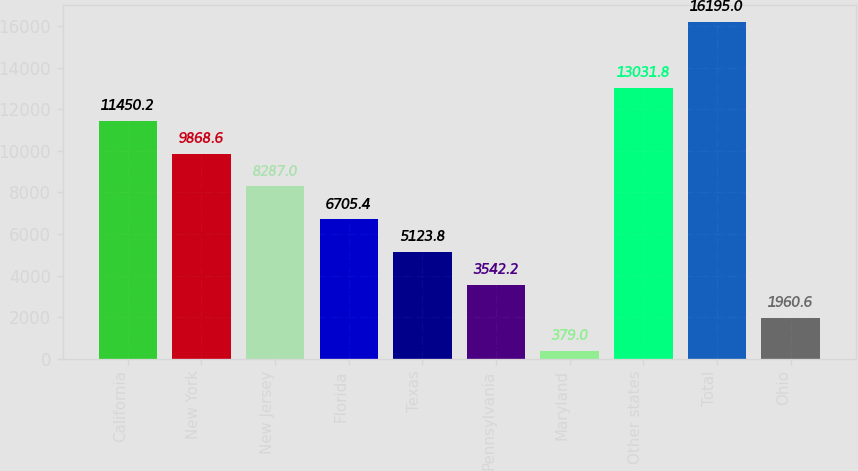Convert chart to OTSL. <chart><loc_0><loc_0><loc_500><loc_500><bar_chart><fcel>California<fcel>New York<fcel>New Jersey<fcel>Florida<fcel>Texas<fcel>Pennsylvania<fcel>Maryland<fcel>Other states<fcel>Total<fcel>Ohio<nl><fcel>11450.2<fcel>9868.6<fcel>8287<fcel>6705.4<fcel>5123.8<fcel>3542.2<fcel>379<fcel>13031.8<fcel>16195<fcel>1960.6<nl></chart> 